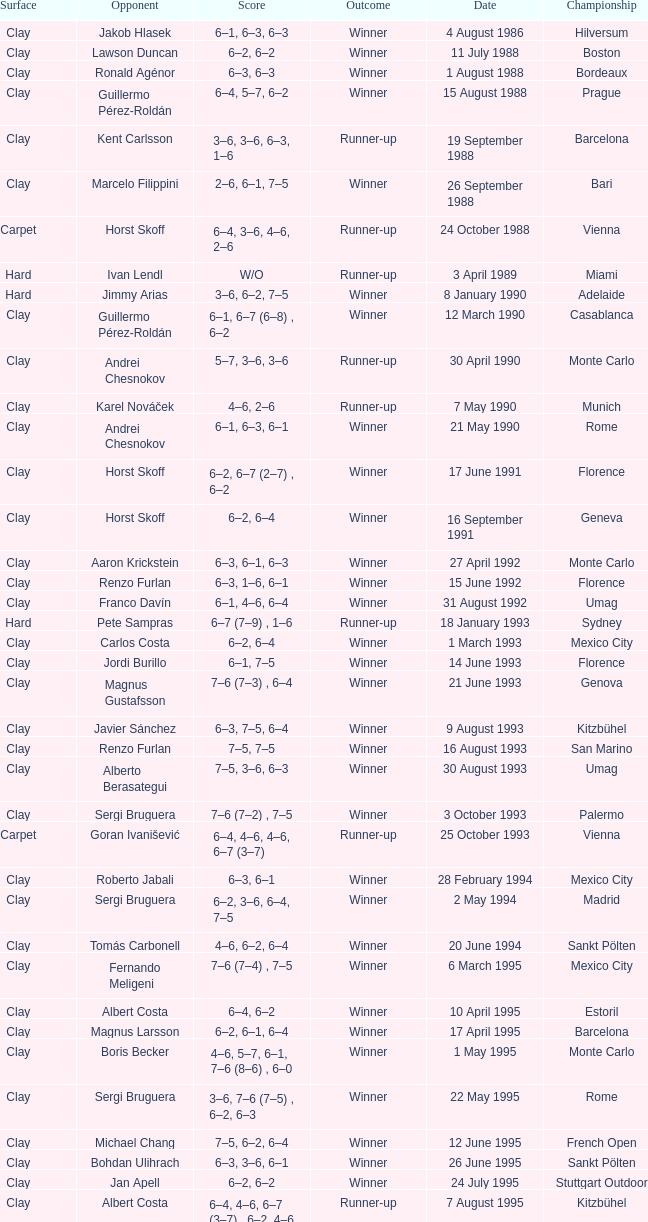What is the surface on 21 june 1993? Clay. 